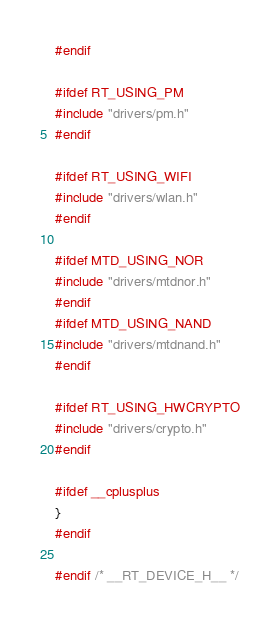Convert code to text. <code><loc_0><loc_0><loc_500><loc_500><_C_>#endif

#ifdef RT_USING_PM
#include "drivers/pm.h"
#endif

#ifdef RT_USING_WIFI
#include "drivers/wlan.h"
#endif

#ifdef MTD_USING_NOR
#include "drivers/mtdnor.h"
#endif
#ifdef MTD_USING_NAND
#include "drivers/mtdnand.h"
#endif

#ifdef RT_USING_HWCRYPTO
#include "drivers/crypto.h"
#endif

#ifdef __cplusplus
}
#endif

#endif /* __RT_DEVICE_H__ */
</code> 